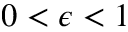<formula> <loc_0><loc_0><loc_500><loc_500>0 < \epsilon < 1</formula> 